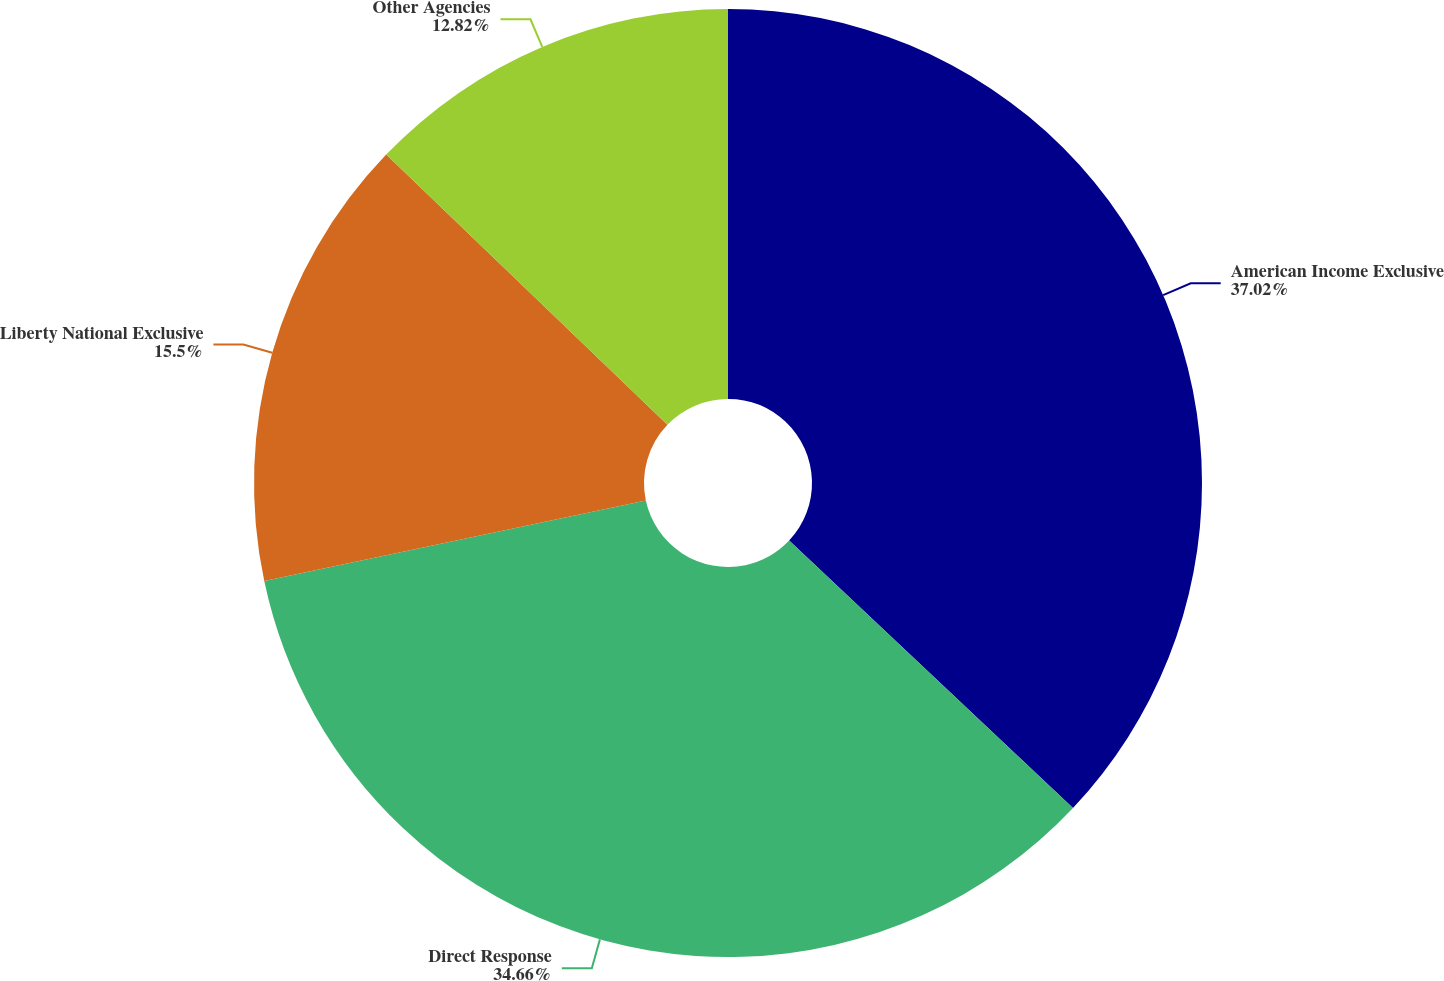<chart> <loc_0><loc_0><loc_500><loc_500><pie_chart><fcel>American Income Exclusive<fcel>Direct Response<fcel>Liberty National Exclusive<fcel>Other Agencies<nl><fcel>37.03%<fcel>34.66%<fcel>15.5%<fcel>12.82%<nl></chart> 